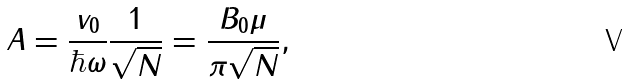<formula> <loc_0><loc_0><loc_500><loc_500>A = \frac { v _ { 0 } } { \hbar { \omega } } \frac { 1 } { \sqrt { N } } = \frac { B _ { 0 } \mu } { \pi \sqrt { N } } ,</formula> 